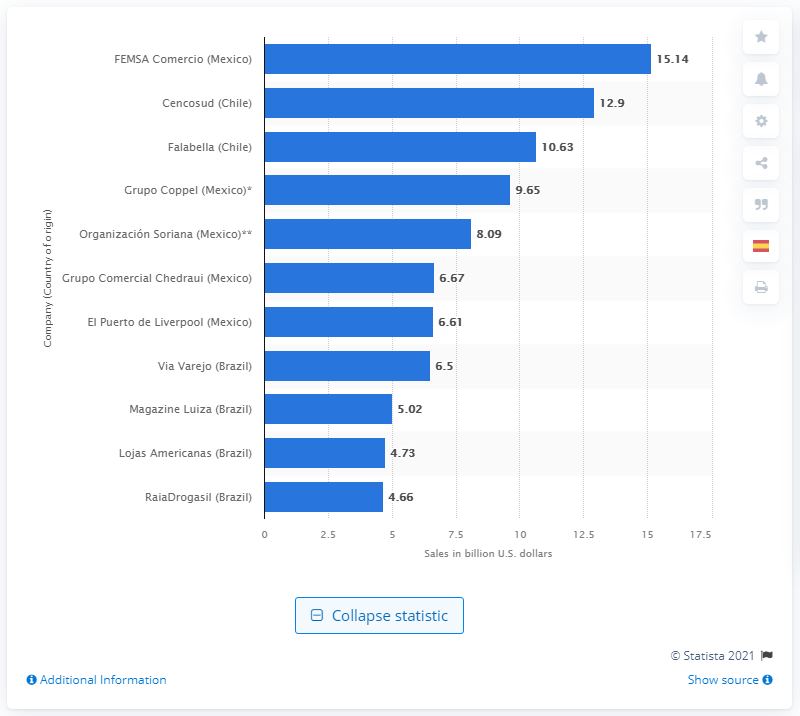Outline some significant characteristics in this image. FEMSA Comercio's sales in U.S. dollars amounted to 15.14 billion in 2019. 